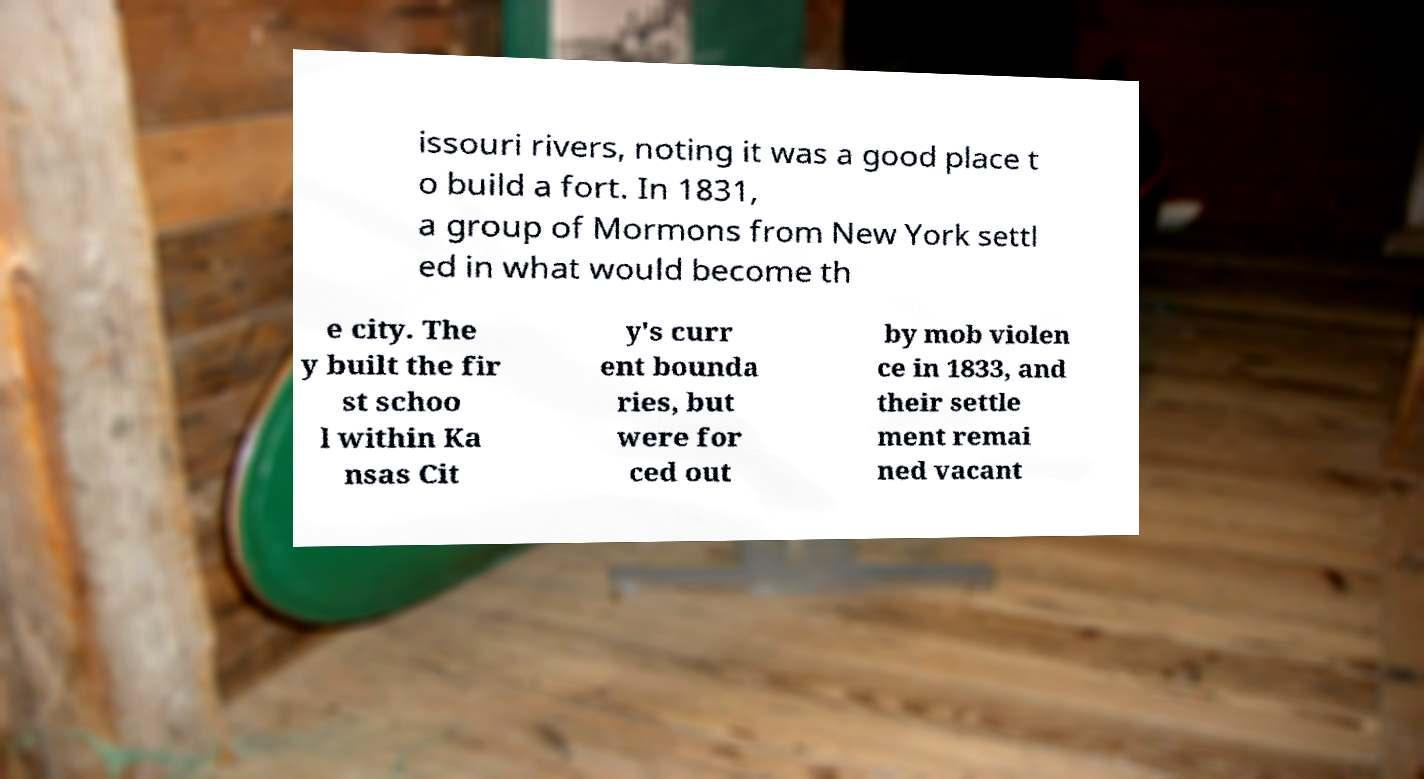Could you extract and type out the text from this image? issouri rivers, noting it was a good place t o build a fort. In 1831, a group of Mormons from New York settl ed in what would become th e city. The y built the fir st schoo l within Ka nsas Cit y's curr ent bounda ries, but were for ced out by mob violen ce in 1833, and their settle ment remai ned vacant 